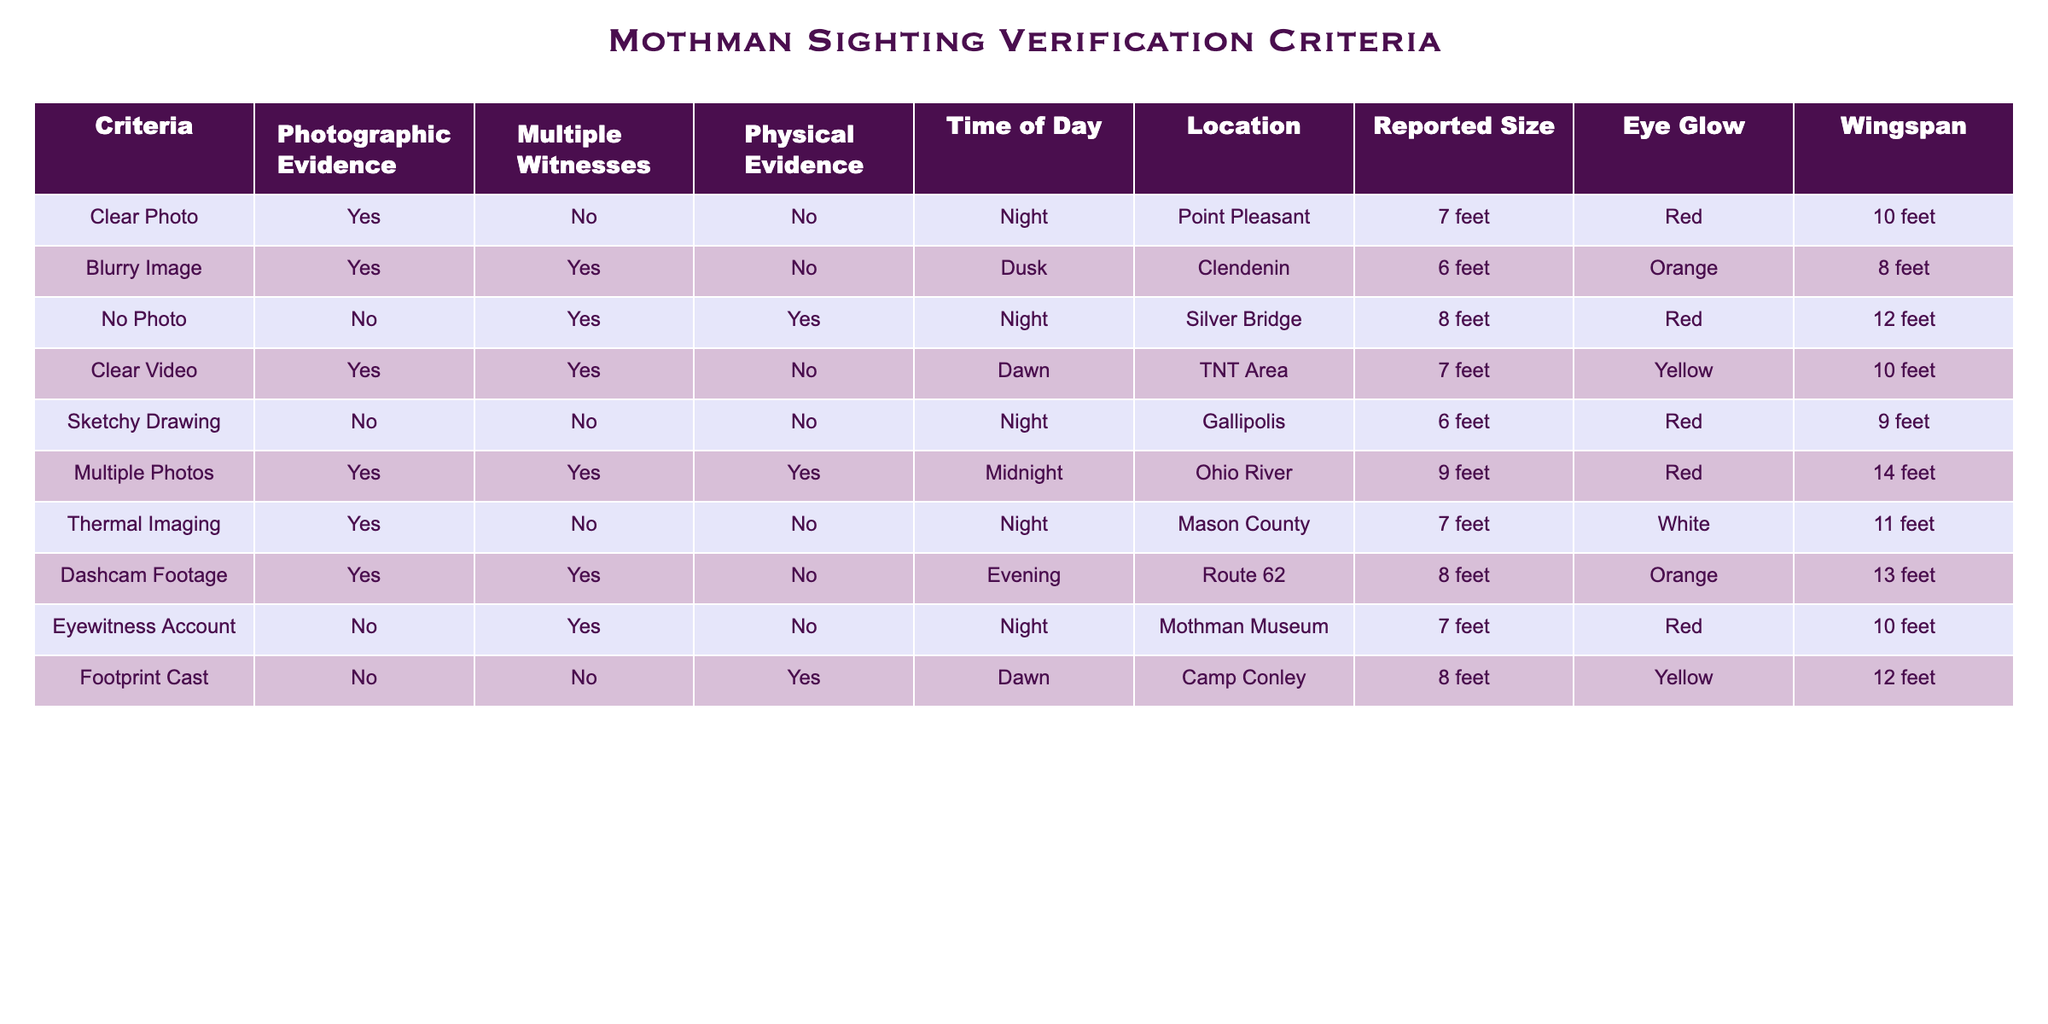What is the size reported for the sighting with multiple photos? In the table, under the "Reported Size" column for the row labeled "Multiple Photos", the value is 9 feet.
Answer: 9 feet Was any sighting reported during the dawn? The table shows that there are two sightings during dawn: "Footprint Cast" (time Dawn) and "Clear Video" (time Dawn) does not have any report; thus Footprint Cast is the only one.
Answer: Yes Which sighting had thermal imaging and what was the wingspan? The "Thermal Imaging" row indicates that the reported wingspan is 11 feet.
Answer: 11 feet How many sightings had no photographic evidence and at night? Looking at the table, we can see that "No Photo" and "Eyewitness Account" have no photographic evidence and both are at night, totaling two sightings.
Answer: 2 Is there a sighting where the size reported was over 10 feet? The "Multiple Photos" has a reported size of 9 feet, and the "No Photo" and "Footprint Cast" have 12 feet; thus the only instance is Footprint Cast.
Answer: Yes Calculate the average reported size of sightings that occurred at night. The reported sizes for sightings at night are 7 feet (Clear Photo), 8 feet (No Photo), 7 feet (Eyewitness Account), and 8 feet (Footprint Cast). Summing these gives 30 feet; dividing by 4 (the number of sightings) results in an average of 7.5 feet.
Answer: 7.5 feet What color eye glow was reported for the sighting at Clendenin? Referring to the table, the sighting labeled "Blurry Image" at Clendenin has an eye glow of orange.
Answer: Orange Which sighting had the largest wingspan? In the table, the wingspan of "Multiple Photos" is listed as 14 feet, which is larger than other sightings.
Answer: 14 feet Are there any findings with no physical evidence but with multiple witnesses? The "Blurry Image" and "Eyewitness Account" categories have multiple witnesses but no physical evidence, confirming this.
Answer: Yes 